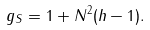Convert formula to latex. <formula><loc_0><loc_0><loc_500><loc_500>g _ { S } = 1 + N ^ { 2 } ( h - 1 ) .</formula> 